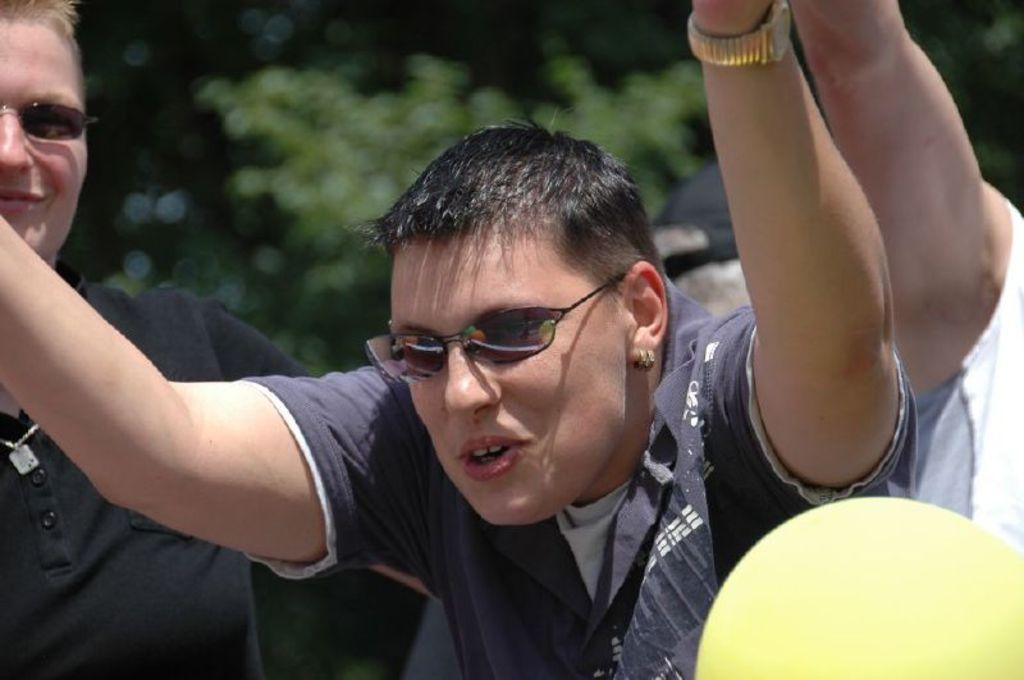Who is present in the image? There are people in the image. What are the people doing in the image? The people are standing. What accessory are the people wearing in the image? The people are wearing sunglasses. Can you see the grandfather sitting by the window in the image? There is no grandfather or window present in the image. Are there any bees buzzing around the people in the image? There are no bees present in the image. 